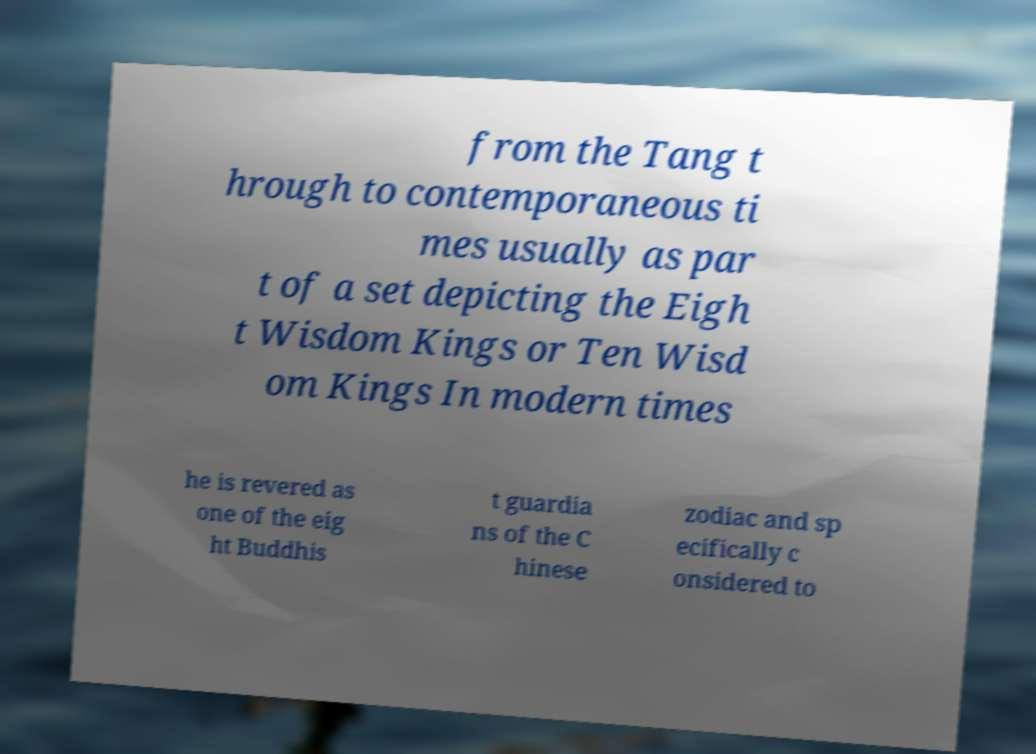What messages or text are displayed in this image? I need them in a readable, typed format. from the Tang t hrough to contemporaneous ti mes usually as par t of a set depicting the Eigh t Wisdom Kings or Ten Wisd om Kings In modern times he is revered as one of the eig ht Buddhis t guardia ns of the C hinese zodiac and sp ecifically c onsidered to 